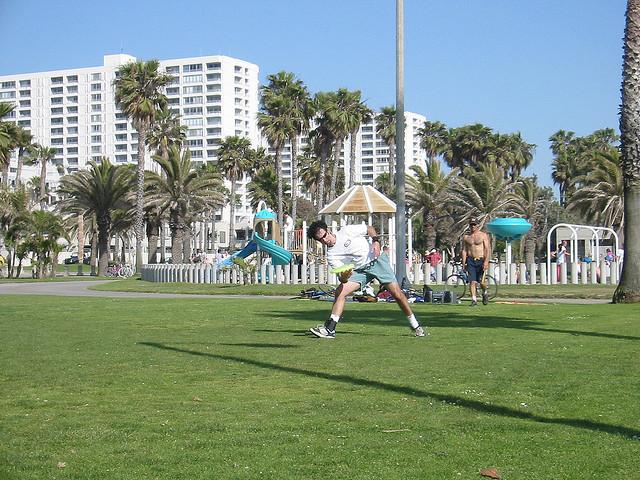What number of palm trees line the park?
Give a very brief answer. Many. What color are the buildings?
Quick response, please. White. If it's 3 pm in the scene, what direction is the Frisbee player facing?
Short answer required. South. Is this climate snowy?
Answer briefly. No. What is the man doing?
Be succinct. Playing frisbee. 